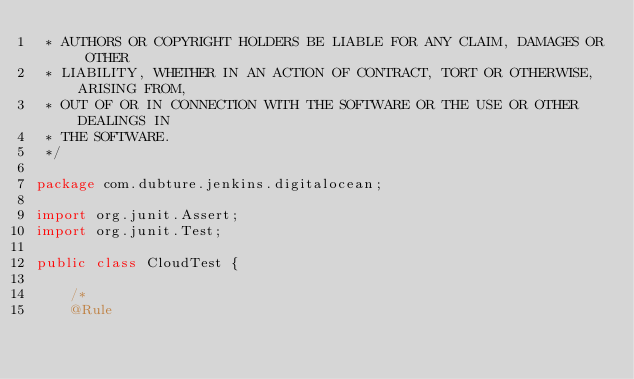<code> <loc_0><loc_0><loc_500><loc_500><_Java_> * AUTHORS OR COPYRIGHT HOLDERS BE LIABLE FOR ANY CLAIM, DAMAGES OR OTHER
 * LIABILITY, WHETHER IN AN ACTION OF CONTRACT, TORT OR OTHERWISE, ARISING FROM,
 * OUT OF OR IN CONNECTION WITH THE SOFTWARE OR THE USE OR OTHER DEALINGS IN
 * THE SOFTWARE.
 */

package com.dubture.jenkins.digitalocean;

import org.junit.Assert;
import org.junit.Test;

public class CloudTest {

    /*
    @Rule</code> 